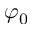<formula> <loc_0><loc_0><loc_500><loc_500>\varphi _ { 0 }</formula> 